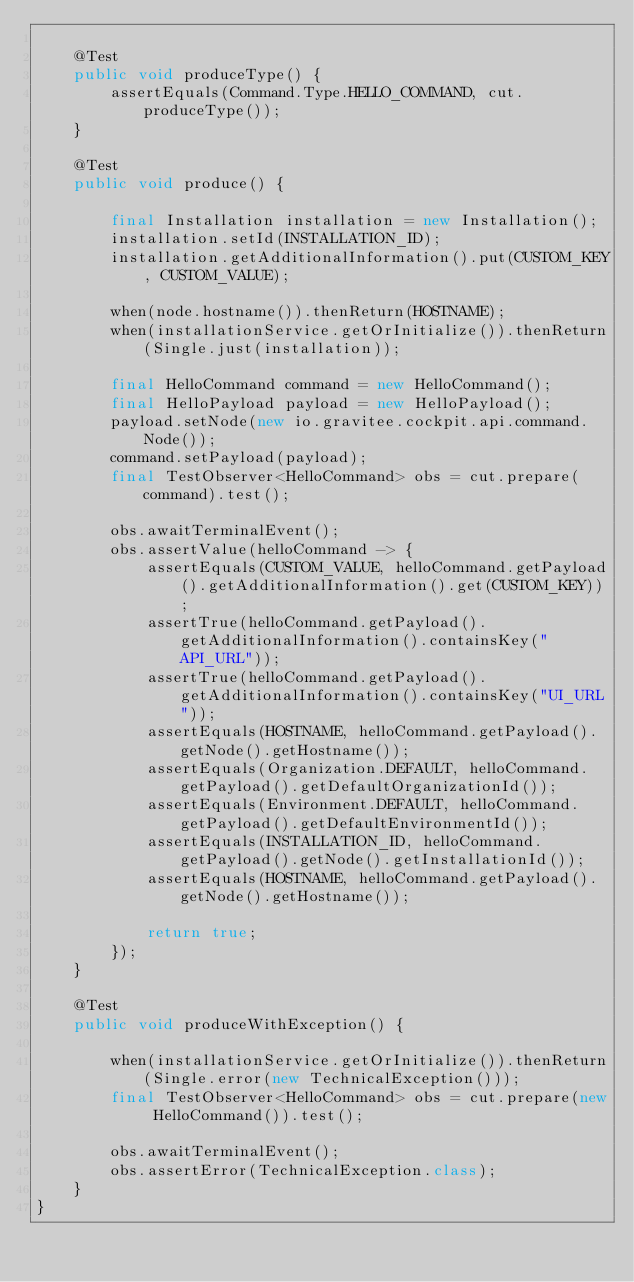Convert code to text. <code><loc_0><loc_0><loc_500><loc_500><_Java_>
    @Test
    public void produceType() {
        assertEquals(Command.Type.HELLO_COMMAND, cut.produceType());
    }

    @Test
    public void produce() {

        final Installation installation = new Installation();
        installation.setId(INSTALLATION_ID);
        installation.getAdditionalInformation().put(CUSTOM_KEY, CUSTOM_VALUE);

        when(node.hostname()).thenReturn(HOSTNAME);
        when(installationService.getOrInitialize()).thenReturn(Single.just(installation));

        final HelloCommand command = new HelloCommand();
        final HelloPayload payload = new HelloPayload();
        payload.setNode(new io.gravitee.cockpit.api.command.Node());
        command.setPayload(payload);
        final TestObserver<HelloCommand> obs = cut.prepare(command).test();

        obs.awaitTerminalEvent();
        obs.assertValue(helloCommand -> {
            assertEquals(CUSTOM_VALUE, helloCommand.getPayload().getAdditionalInformation().get(CUSTOM_KEY));
            assertTrue(helloCommand.getPayload().getAdditionalInformation().containsKey("API_URL"));
            assertTrue(helloCommand.getPayload().getAdditionalInformation().containsKey("UI_URL"));
            assertEquals(HOSTNAME, helloCommand.getPayload().getNode().getHostname());
            assertEquals(Organization.DEFAULT, helloCommand.getPayload().getDefaultOrganizationId());
            assertEquals(Environment.DEFAULT, helloCommand.getPayload().getDefaultEnvironmentId());
            assertEquals(INSTALLATION_ID, helloCommand.getPayload().getNode().getInstallationId());
            assertEquals(HOSTNAME, helloCommand.getPayload().getNode().getHostname());

            return true;
        });
    }

    @Test
    public void produceWithException() {

        when(installationService.getOrInitialize()).thenReturn(Single.error(new TechnicalException()));
        final TestObserver<HelloCommand> obs = cut.prepare(new HelloCommand()).test();

        obs.awaitTerminalEvent();
        obs.assertError(TechnicalException.class);
    }
}</code> 